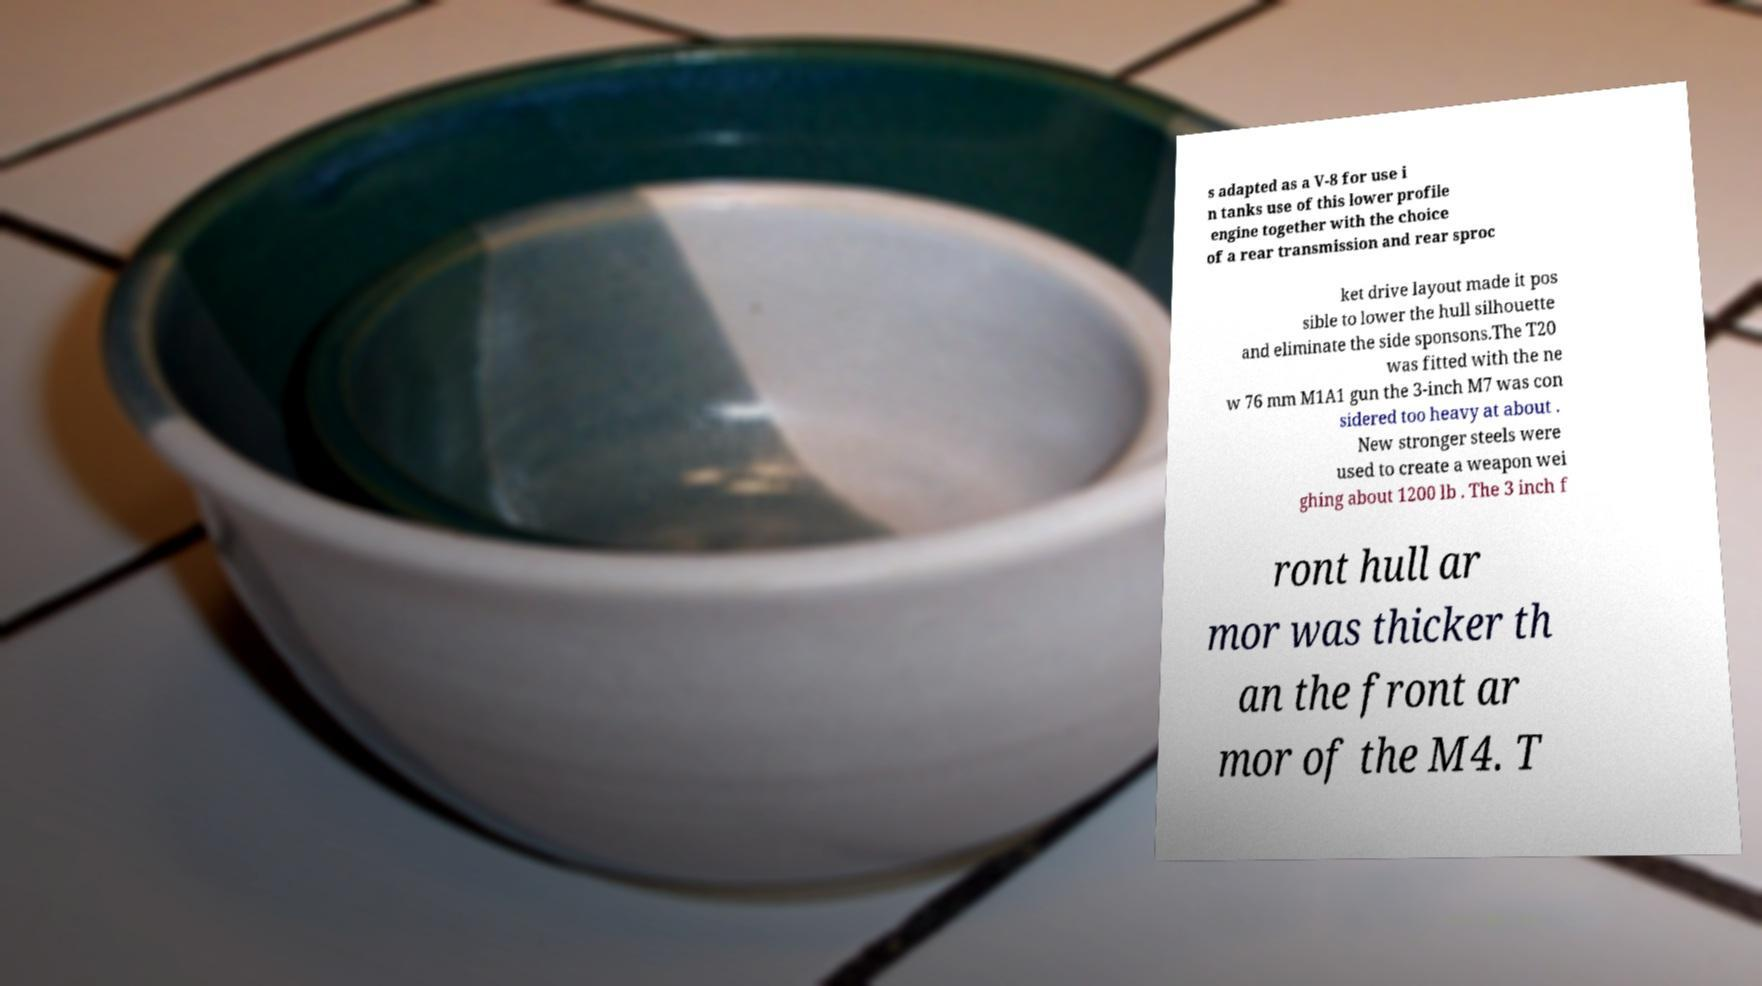Please identify and transcribe the text found in this image. s adapted as a V-8 for use i n tanks use of this lower profile engine together with the choice of a rear transmission and rear sproc ket drive layout made it pos sible to lower the hull silhouette and eliminate the side sponsons.The T20 was fitted with the ne w 76 mm M1A1 gun the 3-inch M7 was con sidered too heavy at about . New stronger steels were used to create a weapon wei ghing about 1200 lb . The 3 inch f ront hull ar mor was thicker th an the front ar mor of the M4. T 